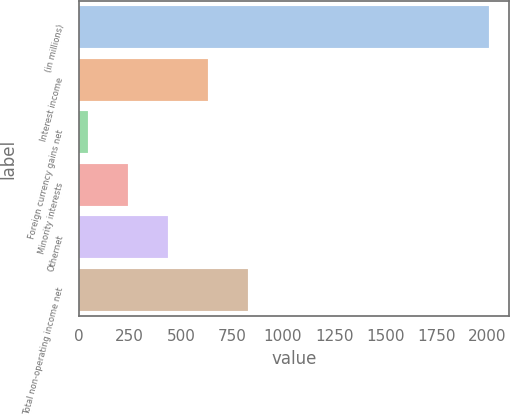Convert chart to OTSL. <chart><loc_0><loc_0><loc_500><loc_500><bar_chart><fcel>(in millions)<fcel>Interest income<fcel>Foreign currency gains net<fcel>Minority interests<fcel>Othernet<fcel>Total non-operating income net<nl><fcel>2007<fcel>633.6<fcel>45<fcel>241.2<fcel>437.4<fcel>829.8<nl></chart> 